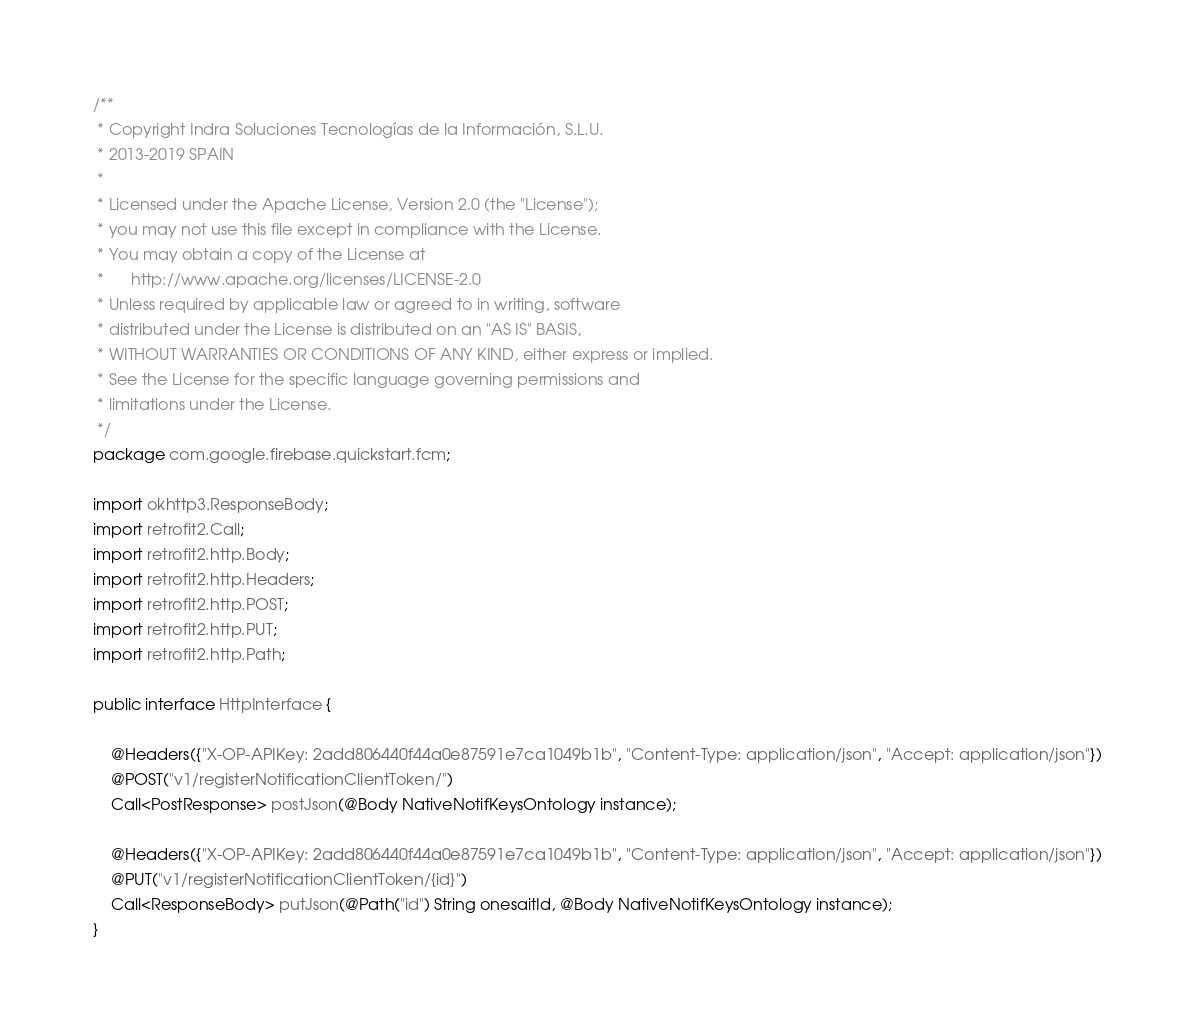Convert code to text. <code><loc_0><loc_0><loc_500><loc_500><_Java_>/**
 * Copyright Indra Soluciones Tecnologías de la Información, S.L.U.
 * 2013-2019 SPAIN
 *
 * Licensed under the Apache License, Version 2.0 (the "License");
 * you may not use this file except in compliance with the License.
 * You may obtain a copy of the License at
 *      http://www.apache.org/licenses/LICENSE-2.0
 * Unless required by applicable law or agreed to in writing, software
 * distributed under the License is distributed on an "AS IS" BASIS,
 * WITHOUT WARRANTIES OR CONDITIONS OF ANY KIND, either express or implied.
 * See the License for the specific language governing permissions and
 * limitations under the License.
 */
package com.google.firebase.quickstart.fcm;

import okhttp3.ResponseBody;
import retrofit2.Call;
import retrofit2.http.Body;
import retrofit2.http.Headers;
import retrofit2.http.POST;
import retrofit2.http.PUT;
import retrofit2.http.Path;

public interface HttpInterface {

    @Headers({"X-OP-APIKey: 2add806440f44a0e87591e7ca1049b1b", "Content-Type: application/json", "Accept: application/json"})
    @POST("v1/registerNotificationClientToken/")
    Call<PostResponse> postJson(@Body NativeNotifKeysOntology instance);

    @Headers({"X-OP-APIKey: 2add806440f44a0e87591e7ca1049b1b", "Content-Type: application/json", "Accept: application/json"})
    @PUT("v1/registerNotificationClientToken/{id}")
    Call<ResponseBody> putJson(@Path("id") String onesaitId, @Body NativeNotifKeysOntology instance);
}
</code> 